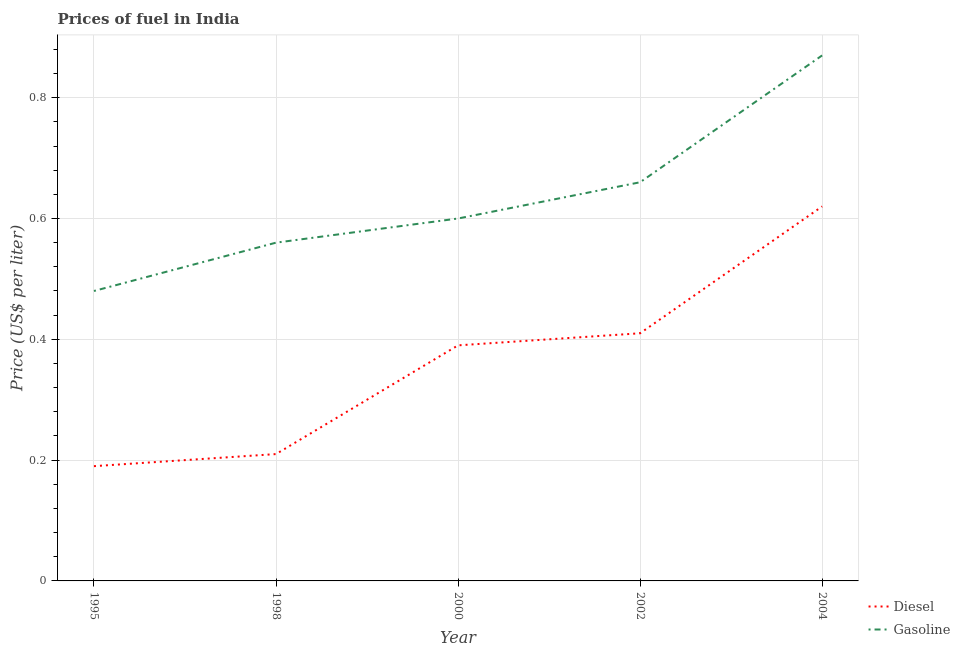Is the number of lines equal to the number of legend labels?
Offer a very short reply. Yes. What is the diesel price in 2002?
Your response must be concise. 0.41. Across all years, what is the maximum diesel price?
Offer a very short reply. 0.62. Across all years, what is the minimum gasoline price?
Give a very brief answer. 0.48. In which year was the gasoline price minimum?
Keep it short and to the point. 1995. What is the total gasoline price in the graph?
Ensure brevity in your answer.  3.17. What is the difference between the gasoline price in 2002 and that in 2004?
Keep it short and to the point. -0.21. What is the difference between the gasoline price in 2002 and the diesel price in 1995?
Your answer should be compact. 0.47. What is the average gasoline price per year?
Your answer should be very brief. 0.63. In the year 1998, what is the difference between the diesel price and gasoline price?
Keep it short and to the point. -0.35. What is the ratio of the diesel price in 2000 to that in 2002?
Offer a terse response. 0.95. What is the difference between the highest and the second highest diesel price?
Make the answer very short. 0.21. What is the difference between the highest and the lowest gasoline price?
Your answer should be very brief. 0.39. In how many years, is the diesel price greater than the average diesel price taken over all years?
Ensure brevity in your answer.  3. Does the gasoline price monotonically increase over the years?
Your response must be concise. Yes. Is the diesel price strictly greater than the gasoline price over the years?
Make the answer very short. No. Is the diesel price strictly less than the gasoline price over the years?
Your answer should be compact. Yes. How many lines are there?
Keep it short and to the point. 2. What is the difference between two consecutive major ticks on the Y-axis?
Provide a short and direct response. 0.2. Are the values on the major ticks of Y-axis written in scientific E-notation?
Your answer should be very brief. No. How are the legend labels stacked?
Your answer should be compact. Vertical. What is the title of the graph?
Offer a terse response. Prices of fuel in India. What is the label or title of the X-axis?
Your answer should be very brief. Year. What is the label or title of the Y-axis?
Provide a succinct answer. Price (US$ per liter). What is the Price (US$ per liter) in Diesel in 1995?
Ensure brevity in your answer.  0.19. What is the Price (US$ per liter) of Gasoline in 1995?
Provide a succinct answer. 0.48. What is the Price (US$ per liter) of Diesel in 1998?
Offer a terse response. 0.21. What is the Price (US$ per liter) in Gasoline in 1998?
Keep it short and to the point. 0.56. What is the Price (US$ per liter) in Diesel in 2000?
Offer a very short reply. 0.39. What is the Price (US$ per liter) in Diesel in 2002?
Give a very brief answer. 0.41. What is the Price (US$ per liter) of Gasoline in 2002?
Offer a very short reply. 0.66. What is the Price (US$ per liter) of Diesel in 2004?
Provide a short and direct response. 0.62. What is the Price (US$ per liter) of Gasoline in 2004?
Your response must be concise. 0.87. Across all years, what is the maximum Price (US$ per liter) in Diesel?
Offer a very short reply. 0.62. Across all years, what is the maximum Price (US$ per liter) in Gasoline?
Make the answer very short. 0.87. Across all years, what is the minimum Price (US$ per liter) in Diesel?
Your answer should be very brief. 0.19. Across all years, what is the minimum Price (US$ per liter) in Gasoline?
Keep it short and to the point. 0.48. What is the total Price (US$ per liter) in Diesel in the graph?
Offer a very short reply. 1.82. What is the total Price (US$ per liter) in Gasoline in the graph?
Your answer should be very brief. 3.17. What is the difference between the Price (US$ per liter) in Diesel in 1995 and that in 1998?
Keep it short and to the point. -0.02. What is the difference between the Price (US$ per liter) in Gasoline in 1995 and that in 1998?
Ensure brevity in your answer.  -0.08. What is the difference between the Price (US$ per liter) in Gasoline in 1995 and that in 2000?
Offer a very short reply. -0.12. What is the difference between the Price (US$ per liter) in Diesel in 1995 and that in 2002?
Ensure brevity in your answer.  -0.22. What is the difference between the Price (US$ per liter) in Gasoline in 1995 and that in 2002?
Your answer should be compact. -0.18. What is the difference between the Price (US$ per liter) of Diesel in 1995 and that in 2004?
Your response must be concise. -0.43. What is the difference between the Price (US$ per liter) of Gasoline in 1995 and that in 2004?
Provide a succinct answer. -0.39. What is the difference between the Price (US$ per liter) of Diesel in 1998 and that in 2000?
Offer a very short reply. -0.18. What is the difference between the Price (US$ per liter) in Gasoline in 1998 and that in 2000?
Offer a very short reply. -0.04. What is the difference between the Price (US$ per liter) in Diesel in 1998 and that in 2002?
Ensure brevity in your answer.  -0.2. What is the difference between the Price (US$ per liter) in Gasoline in 1998 and that in 2002?
Provide a short and direct response. -0.1. What is the difference between the Price (US$ per liter) in Diesel in 1998 and that in 2004?
Your answer should be compact. -0.41. What is the difference between the Price (US$ per liter) of Gasoline in 1998 and that in 2004?
Your answer should be very brief. -0.31. What is the difference between the Price (US$ per liter) of Diesel in 2000 and that in 2002?
Make the answer very short. -0.02. What is the difference between the Price (US$ per liter) in Gasoline in 2000 and that in 2002?
Your answer should be very brief. -0.06. What is the difference between the Price (US$ per liter) of Diesel in 2000 and that in 2004?
Give a very brief answer. -0.23. What is the difference between the Price (US$ per liter) of Gasoline in 2000 and that in 2004?
Provide a short and direct response. -0.27. What is the difference between the Price (US$ per liter) of Diesel in 2002 and that in 2004?
Make the answer very short. -0.21. What is the difference between the Price (US$ per liter) of Gasoline in 2002 and that in 2004?
Provide a short and direct response. -0.21. What is the difference between the Price (US$ per liter) in Diesel in 1995 and the Price (US$ per liter) in Gasoline in 1998?
Keep it short and to the point. -0.37. What is the difference between the Price (US$ per liter) in Diesel in 1995 and the Price (US$ per liter) in Gasoline in 2000?
Keep it short and to the point. -0.41. What is the difference between the Price (US$ per liter) of Diesel in 1995 and the Price (US$ per liter) of Gasoline in 2002?
Provide a short and direct response. -0.47. What is the difference between the Price (US$ per liter) in Diesel in 1995 and the Price (US$ per liter) in Gasoline in 2004?
Offer a terse response. -0.68. What is the difference between the Price (US$ per liter) in Diesel in 1998 and the Price (US$ per liter) in Gasoline in 2000?
Provide a short and direct response. -0.39. What is the difference between the Price (US$ per liter) of Diesel in 1998 and the Price (US$ per liter) of Gasoline in 2002?
Give a very brief answer. -0.45. What is the difference between the Price (US$ per liter) in Diesel in 1998 and the Price (US$ per liter) in Gasoline in 2004?
Your answer should be very brief. -0.66. What is the difference between the Price (US$ per liter) of Diesel in 2000 and the Price (US$ per liter) of Gasoline in 2002?
Keep it short and to the point. -0.27. What is the difference between the Price (US$ per liter) of Diesel in 2000 and the Price (US$ per liter) of Gasoline in 2004?
Make the answer very short. -0.48. What is the difference between the Price (US$ per liter) of Diesel in 2002 and the Price (US$ per liter) of Gasoline in 2004?
Ensure brevity in your answer.  -0.46. What is the average Price (US$ per liter) of Diesel per year?
Make the answer very short. 0.36. What is the average Price (US$ per liter) in Gasoline per year?
Provide a short and direct response. 0.63. In the year 1995, what is the difference between the Price (US$ per liter) of Diesel and Price (US$ per liter) of Gasoline?
Your response must be concise. -0.29. In the year 1998, what is the difference between the Price (US$ per liter) of Diesel and Price (US$ per liter) of Gasoline?
Your answer should be very brief. -0.35. In the year 2000, what is the difference between the Price (US$ per liter) of Diesel and Price (US$ per liter) of Gasoline?
Keep it short and to the point. -0.21. In the year 2004, what is the difference between the Price (US$ per liter) in Diesel and Price (US$ per liter) in Gasoline?
Offer a very short reply. -0.25. What is the ratio of the Price (US$ per liter) in Diesel in 1995 to that in 1998?
Provide a succinct answer. 0.9. What is the ratio of the Price (US$ per liter) in Diesel in 1995 to that in 2000?
Your answer should be compact. 0.49. What is the ratio of the Price (US$ per liter) in Diesel in 1995 to that in 2002?
Your answer should be very brief. 0.46. What is the ratio of the Price (US$ per liter) in Gasoline in 1995 to that in 2002?
Ensure brevity in your answer.  0.73. What is the ratio of the Price (US$ per liter) of Diesel in 1995 to that in 2004?
Ensure brevity in your answer.  0.31. What is the ratio of the Price (US$ per liter) in Gasoline in 1995 to that in 2004?
Provide a short and direct response. 0.55. What is the ratio of the Price (US$ per liter) in Diesel in 1998 to that in 2000?
Provide a short and direct response. 0.54. What is the ratio of the Price (US$ per liter) in Gasoline in 1998 to that in 2000?
Ensure brevity in your answer.  0.93. What is the ratio of the Price (US$ per liter) in Diesel in 1998 to that in 2002?
Your answer should be very brief. 0.51. What is the ratio of the Price (US$ per liter) in Gasoline in 1998 to that in 2002?
Your response must be concise. 0.85. What is the ratio of the Price (US$ per liter) of Diesel in 1998 to that in 2004?
Give a very brief answer. 0.34. What is the ratio of the Price (US$ per liter) of Gasoline in 1998 to that in 2004?
Provide a short and direct response. 0.64. What is the ratio of the Price (US$ per liter) in Diesel in 2000 to that in 2002?
Keep it short and to the point. 0.95. What is the ratio of the Price (US$ per liter) of Gasoline in 2000 to that in 2002?
Your response must be concise. 0.91. What is the ratio of the Price (US$ per liter) of Diesel in 2000 to that in 2004?
Your answer should be very brief. 0.63. What is the ratio of the Price (US$ per liter) of Gasoline in 2000 to that in 2004?
Your answer should be very brief. 0.69. What is the ratio of the Price (US$ per liter) of Diesel in 2002 to that in 2004?
Make the answer very short. 0.66. What is the ratio of the Price (US$ per liter) in Gasoline in 2002 to that in 2004?
Make the answer very short. 0.76. What is the difference between the highest and the second highest Price (US$ per liter) in Diesel?
Make the answer very short. 0.21. What is the difference between the highest and the second highest Price (US$ per liter) of Gasoline?
Your response must be concise. 0.21. What is the difference between the highest and the lowest Price (US$ per liter) of Diesel?
Ensure brevity in your answer.  0.43. What is the difference between the highest and the lowest Price (US$ per liter) of Gasoline?
Make the answer very short. 0.39. 